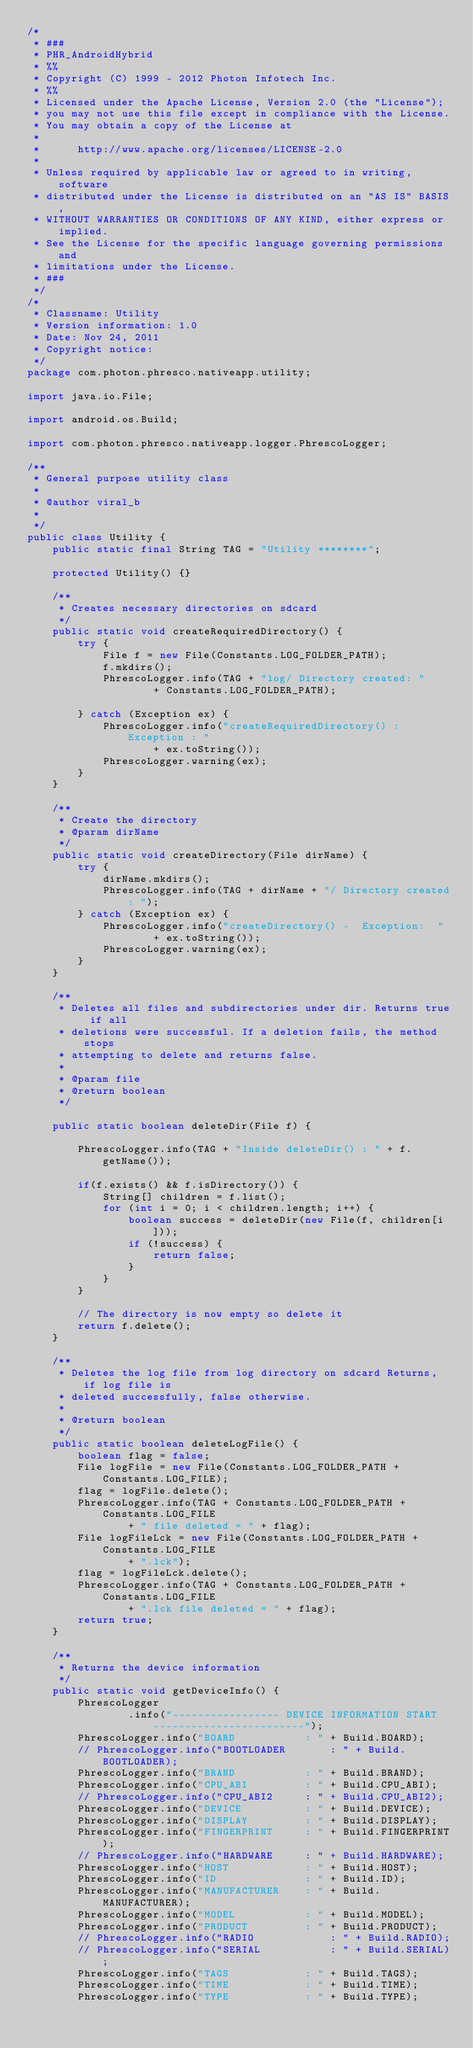Convert code to text. <code><loc_0><loc_0><loc_500><loc_500><_Java_>/*
 * ###
 * PHR_AndroidHybrid
 * %%
 * Copyright (C) 1999 - 2012 Photon Infotech Inc.
 * %%
 * Licensed under the Apache License, Version 2.0 (the "License");
 * you may not use this file except in compliance with the License.
 * You may obtain a copy of the License at
 * 
 *      http://www.apache.org/licenses/LICENSE-2.0
 * 
 * Unless required by applicable law or agreed to in writing, software
 * distributed under the License is distributed on an "AS IS" BASIS,
 * WITHOUT WARRANTIES OR CONDITIONS OF ANY KIND, either express or implied.
 * See the License for the specific language governing permissions and
 * limitations under the License.
 * ###
 */
/*
 * Classname: Utility
 * Version information: 1.0
 * Date: Nov 24, 2011
 * Copyright notice:
 */
package com.photon.phresco.nativeapp.utility;

import java.io.File;

import android.os.Build;

import com.photon.phresco.nativeapp.logger.PhrescoLogger;

/**
 * General purpose utility class
 *
 * @author viral_b
 *
 */
public class Utility {
	public static final String TAG = "Utility ********";

	protected Utility() {}

	/**
	 * Creates necessary directories on sdcard
	 */
	public static void createRequiredDirectory() {
		try {
			File f = new File(Constants.LOG_FOLDER_PATH);
			f.mkdirs();
			PhrescoLogger.info(TAG + "log/ Directory created: "
					+ Constants.LOG_FOLDER_PATH);

		} catch (Exception ex) {
			PhrescoLogger.info("createRequiredDirectory() : Exception : "
					+ ex.toString());
			PhrescoLogger.warning(ex);
		}
	}

	/**
	 * Create the directory
	 * @param dirName
	 */
	public static void createDirectory(File dirName) {
		try {
			dirName.mkdirs();
			PhrescoLogger.info(TAG + dirName + "/ Directory created: ");
		} catch (Exception ex) {
			PhrescoLogger.info("createDirectory() -  Exception:  "
					+ ex.toString());
			PhrescoLogger.warning(ex);
		}
	}

	/**
	 * Deletes all files and subdirectories under dir. Returns true if all
	 * deletions were successful. If a deletion fails, the method stops
	 * attempting to delete and returns false.
	 *
	 * @param file
	 * @return boolean
	 */

	public static boolean deleteDir(File f) {

		PhrescoLogger.info(TAG + "Inside deleteDir() : " + f.getName());

		if(f.exists() && f.isDirectory()) {
			String[] children = f.list();
			for (int i = 0; i < children.length; i++) {
				boolean success = deleteDir(new File(f, children[i]));
				if (!success) {
					return false;
				}
			}
		}

		// The directory is now empty so delete it
		return f.delete();
	}

	/**
	 * Deletes the log file from log directory on sdcard Returns, if log file is
	 * deleted successfully, false otherwise.
	 *
	 * @return boolean
	 */
	public static boolean deleteLogFile() {
		boolean flag = false;
		File logFile = new File(Constants.LOG_FOLDER_PATH + Constants.LOG_FILE);
		flag = logFile.delete();
		PhrescoLogger.info(TAG + Constants.LOG_FOLDER_PATH + Constants.LOG_FILE
				+ " file deleted = " + flag);
		File logFileLck = new File(Constants.LOG_FOLDER_PATH + Constants.LOG_FILE
				+ ".lck");
		flag = logFileLck.delete();
		PhrescoLogger.info(TAG + Constants.LOG_FOLDER_PATH + Constants.LOG_FILE
				+ ".lck file deleted = " + flag);
		return true;
	}

	/**
	 * Returns the device information
	 */
	public static void getDeviceInfo() {
		PhrescoLogger
				.info("----------------- DEVICE INFORMATION START ------------------------");
		PhrescoLogger.info("BOARD 			: " + Build.BOARD);
		// PhrescoLogger.info("BOOTLOADER 		: " + Build.BOOTLOADER);
		PhrescoLogger.info("BRAND 			: " + Build.BRAND);
		PhrescoLogger.info("CPU_ABI			: " + Build.CPU_ABI);
		// PhrescoLogger.info("CPU_ABI2		: " + Build.CPU_ABI2);
		PhrescoLogger.info("DEVICE 			: " + Build.DEVICE);
		PhrescoLogger.info("DISPLAY 		: " + Build.DISPLAY);
		PhrescoLogger.info("FINGERPRINT 	: " + Build.FINGERPRINT);
		// PhrescoLogger.info("HARDWARE		: " + Build.HARDWARE);
		PhrescoLogger.info("HOST 			: " + Build.HOST);
		PhrescoLogger.info("ID 				: " + Build.ID);
		PhrescoLogger.info("MANUFACTURER	: " + Build.MANUFACTURER);
		PhrescoLogger.info("MODEL 			: " + Build.MODEL);
		PhrescoLogger.info("PRODUCT 		: " + Build.PRODUCT);
		// PhrescoLogger.info("RADIO	 		: " + Build.RADIO);
		// PhrescoLogger.info("SERIAL	 		: " + Build.SERIAL);
		PhrescoLogger.info("TAGS 			: " + Build.TAGS);
		PhrescoLogger.info("TIME 			: " + Build.TIME);
		PhrescoLogger.info("TYPE 			: " + Build.TYPE);</code> 